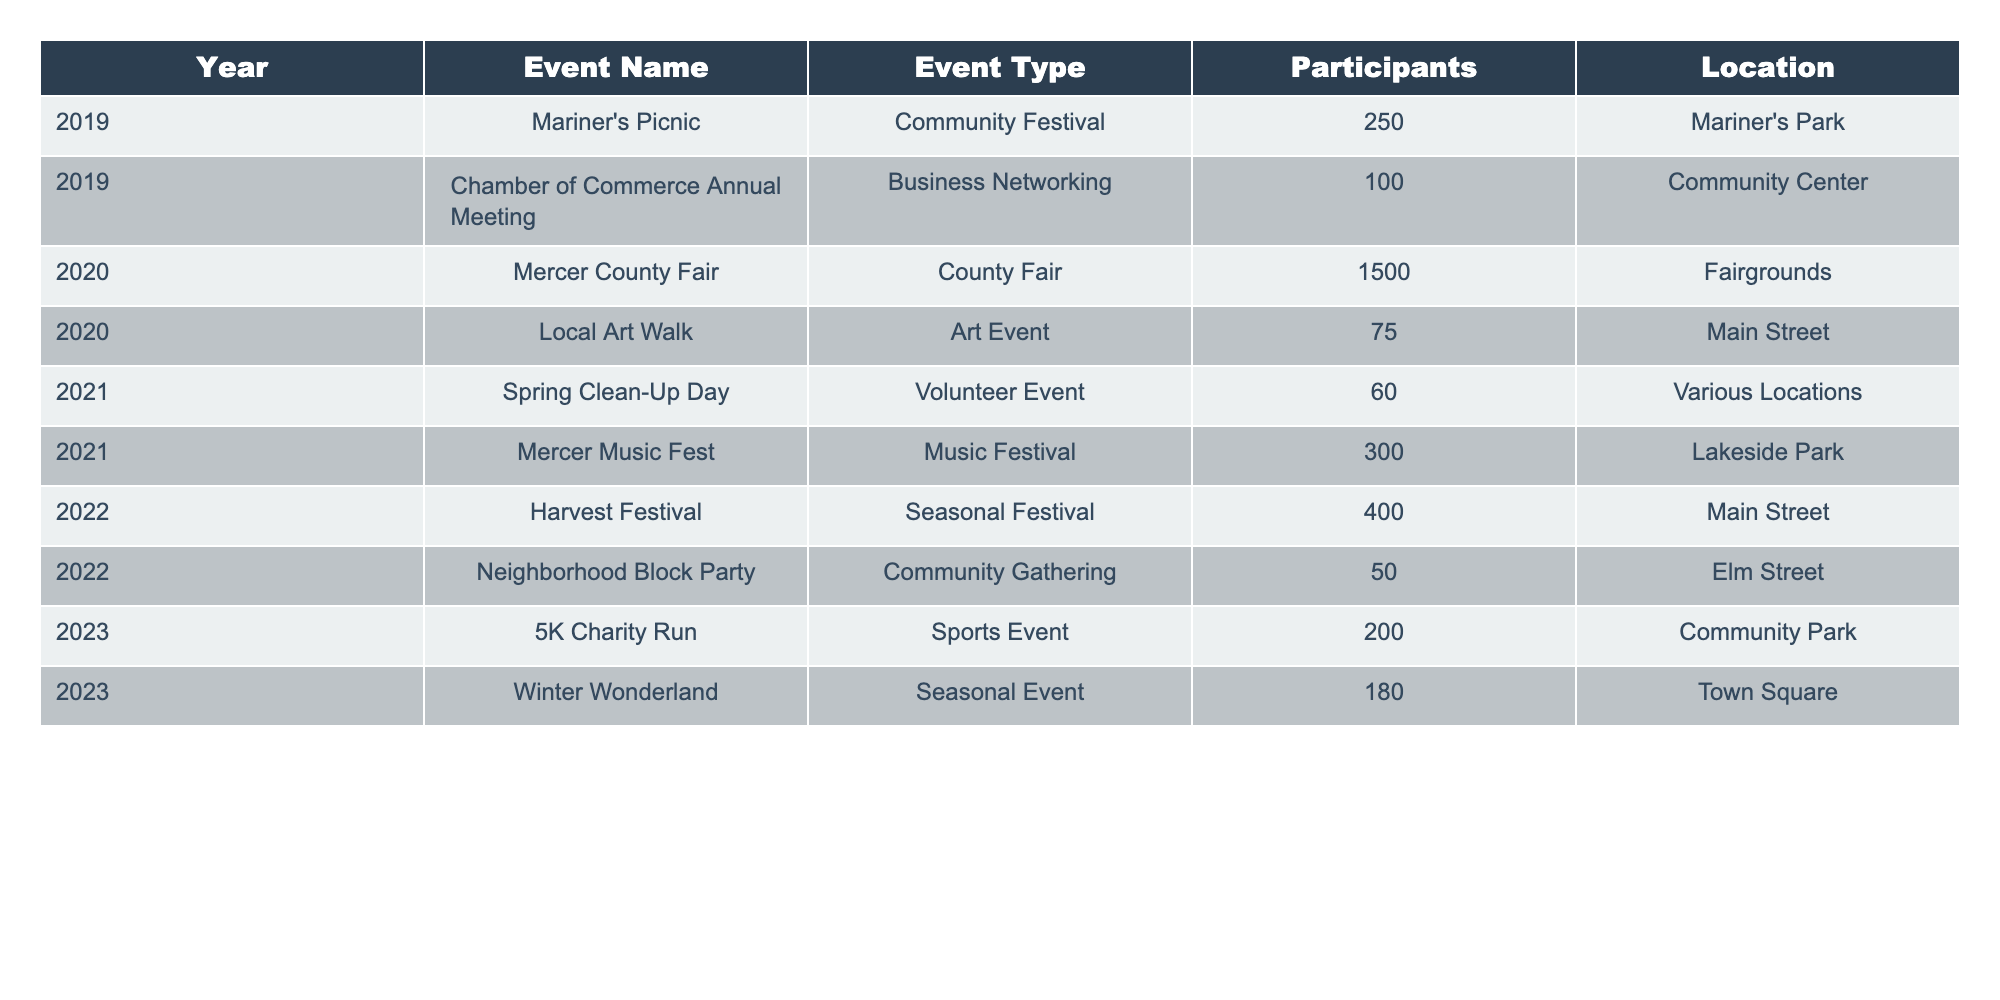What is the total number of participants across all events in 2022? The participants for events in 2022 are 400 (Harvest Festival) and 50 (Neighborhood Block Party). Adding them gives 400 + 50 = 450.
Answer: 450 Which event had the highest number of participants in 2020? The table lists the Mercer County Fair with 1500 participants as the only event in 2020, which is the highest.
Answer: Mercer County Fair How many different types of events were held in 2021? The events listed for 2021 are Spring Clean-Up Day (Volunteer Event) and Mercer Music Fest (Music Festival), making a total of 2 different types.
Answer: 2 In which year was the least attended event, and what was the number of participants? The Local Art Walk in 2020 had the least attendance with 75 participants. Comparing all events, this is the lowest.
Answer: 2020, 75 What is the average number of participants per event for the year 2019? The events for 2019 are Mariner's Picnic (250) and Chamber of Commerce Annual Meeting (100). The average is (250 + 100) / 2 = 175.
Answer: 175 Was there an increase in participants from 2021 to 2022? The total participants in 2021 are 60 (Spring Clean-Up Day) + 300 (Mercer Music Fest) = 360. In 2022, it's 450. Since 450 > 360, there was an increase.
Answer: Yes Which event type had the highest participation in the last five years? The County Fair in 2020 had 1500 participants, which is higher than any other event type in the past five years.
Answer: County Fair How many events were held at Main Street, and what was the total participation? The events at Main Street are the Local Art Walk (75 participants) in 2020 and Harvest Festival (400 participants) in 2022. Summing them gives 75 + 400 = 475.
Answer: 2 events, 475 participants What is the percentage of participants in the 2023 events compared to the 2019 events? The total participants in 2023 are 200 (5K Charity Run) + 180 (Winter Wonderland) = 380. The total in 2019 is 350 (250 + 100). The percentage is (380 / 350) * 100 = 108.57%.
Answer: 108.57% Which year had more events, 2021 or 2022? 2021 had 2 events (Spring Clean-Up Day and Mercer Music Fest), while 2022 had 2 events (Harvest Festival and Neighborhood Block Party), so they are equal.
Answer: Equal (2 events each) 